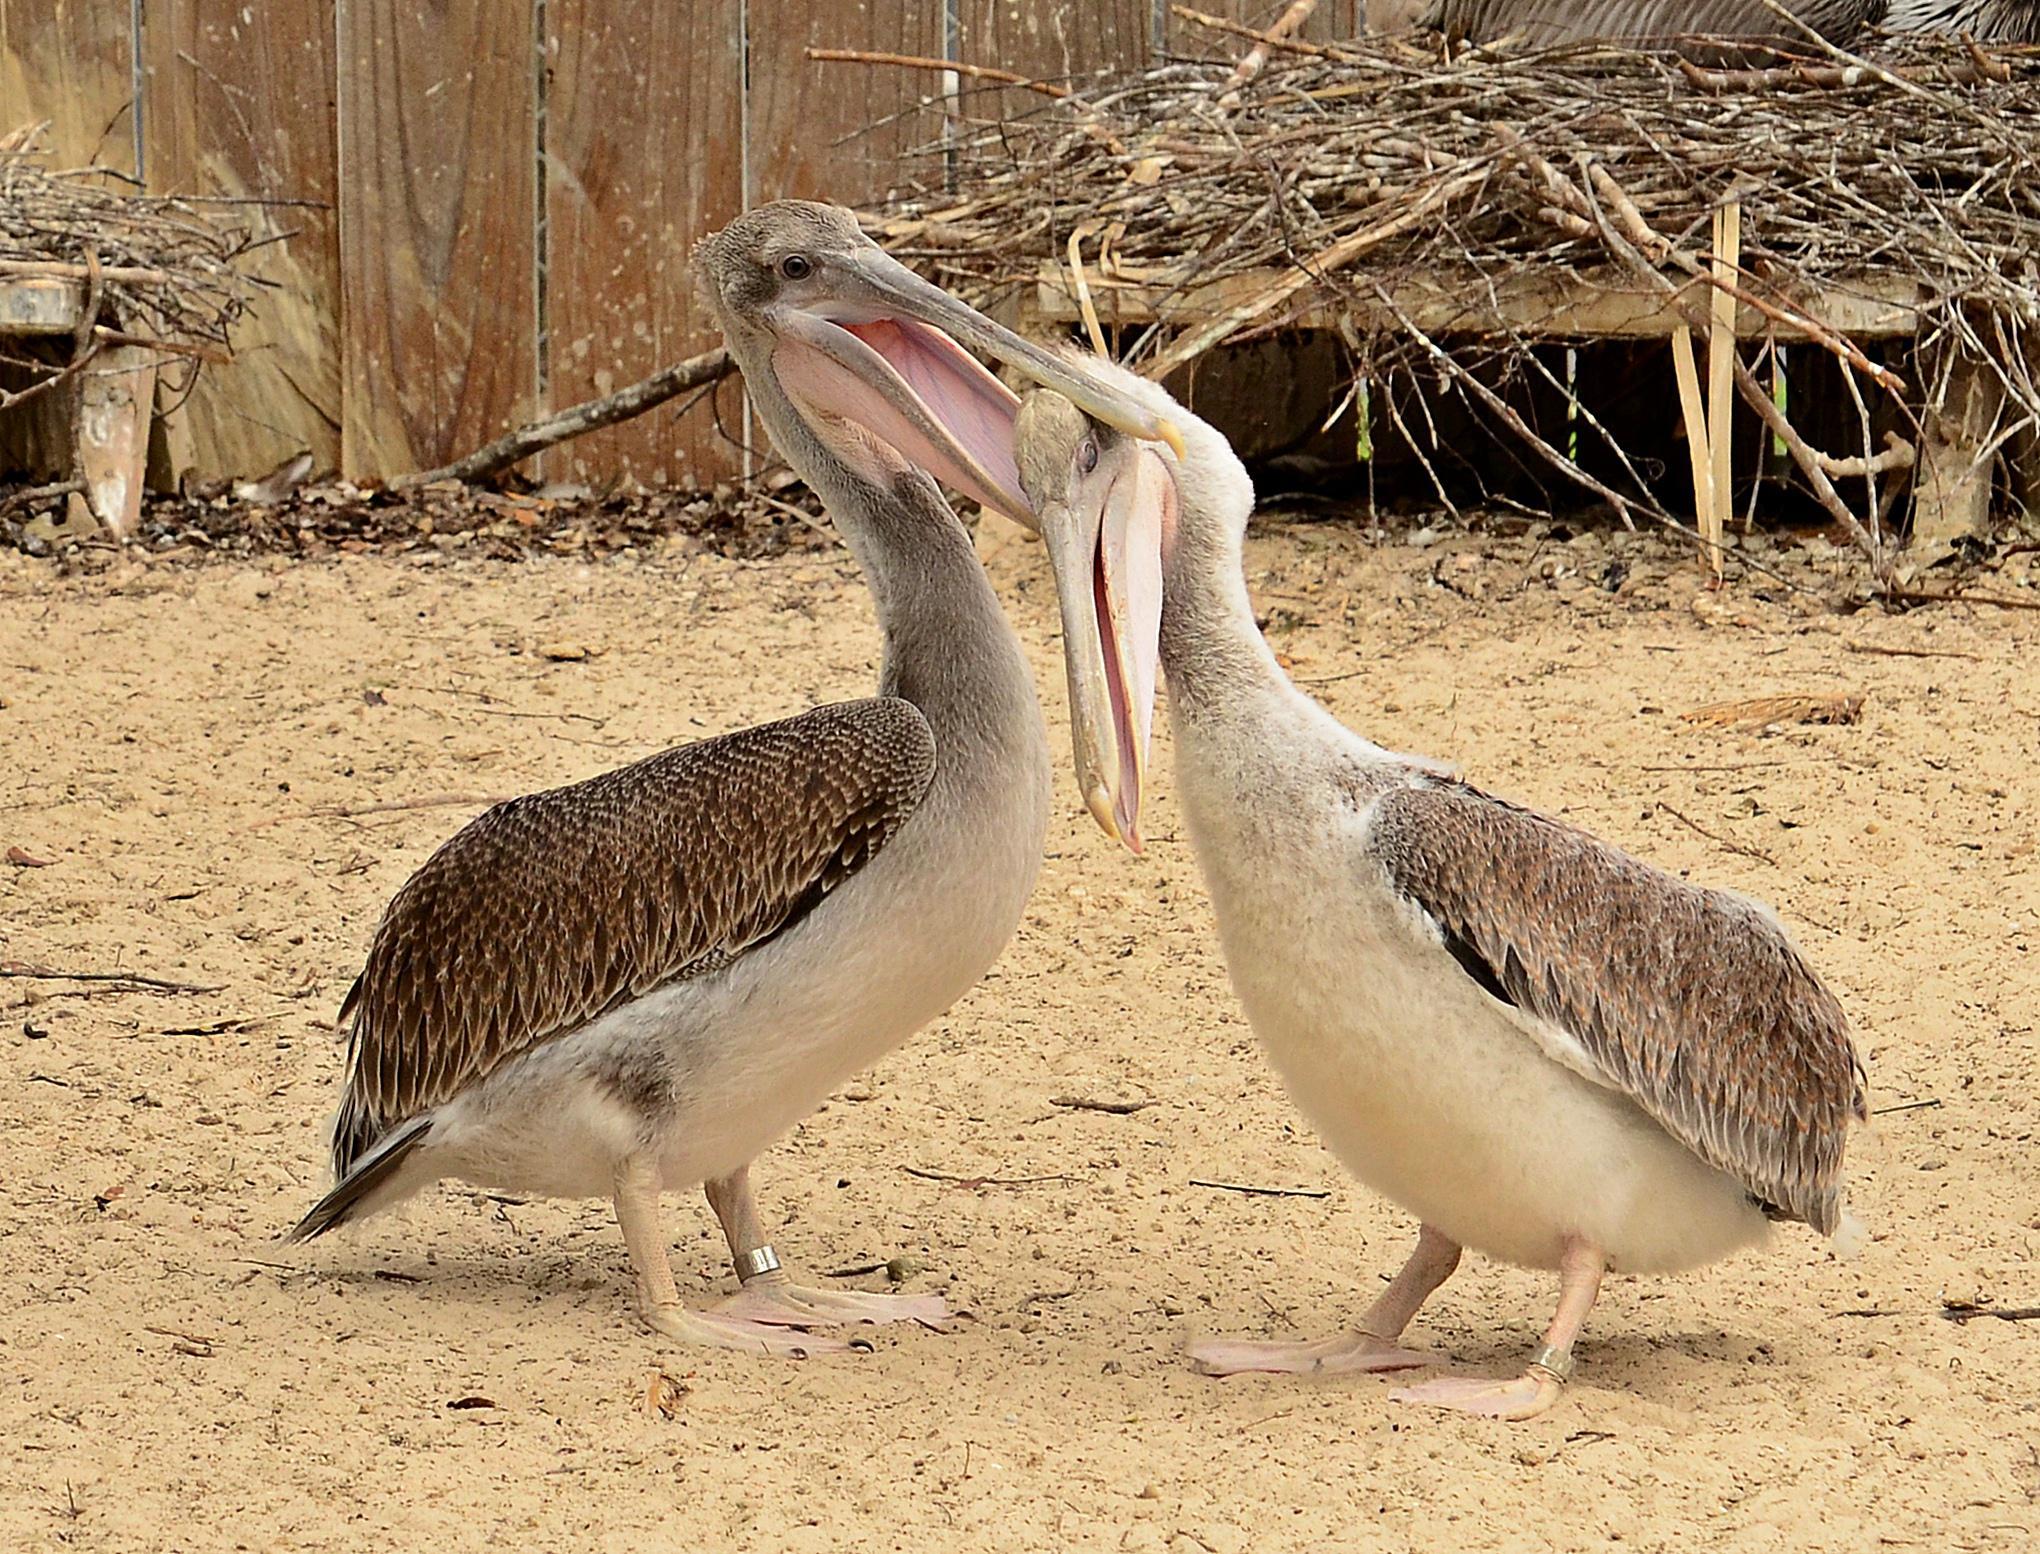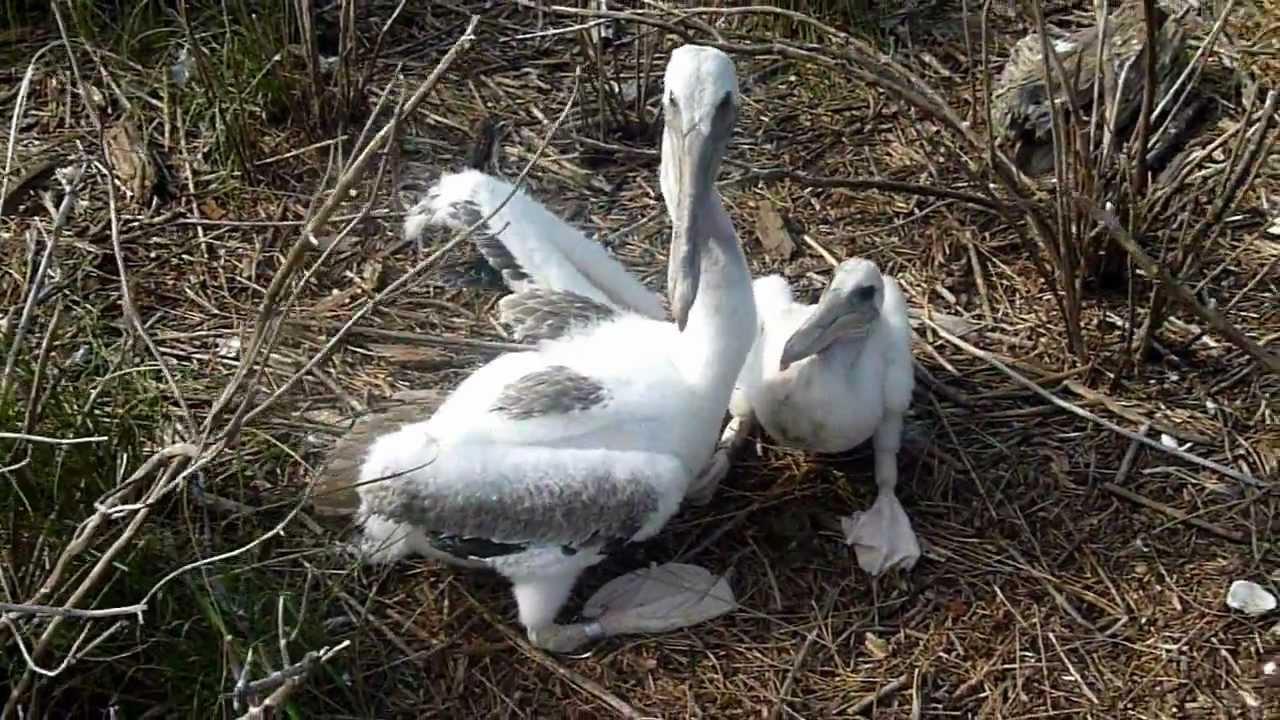The first image is the image on the left, the second image is the image on the right. Assess this claim about the two images: "An image shows exactly two juvenile pelicans with fuzzy white feathers posed close together.". Correct or not? Answer yes or no. Yes. 